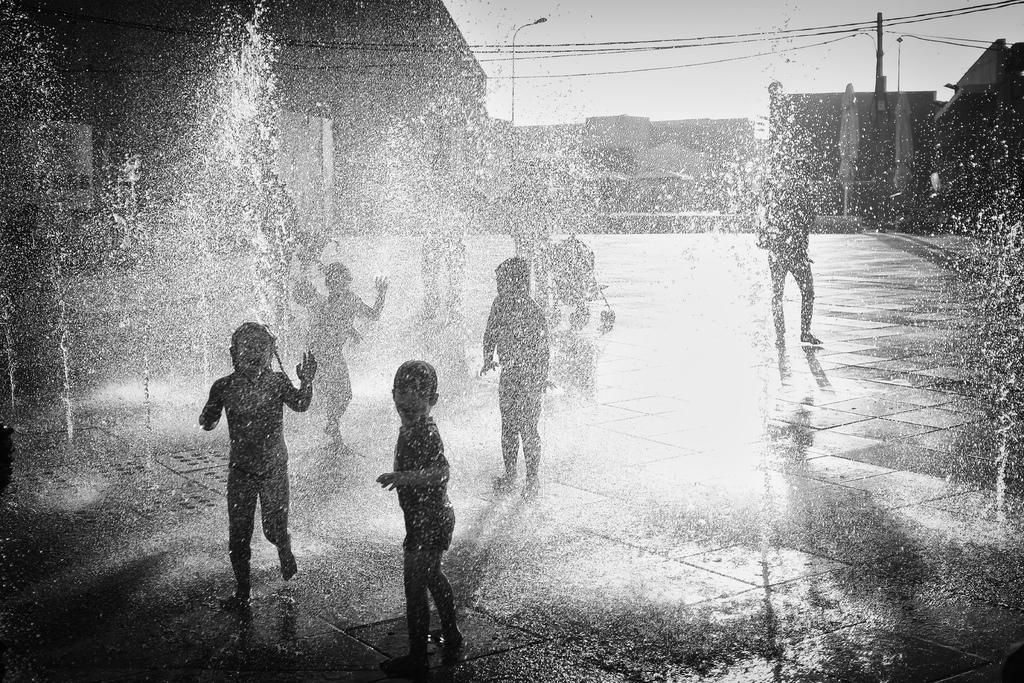What are the people in the image doing? The people in the image are standing in the middle. What is located near the people? There is a stroller in the image. What can be seen in the foreground of the image? Water is visible in the image. What is visible in the background of the image? There are poles and buildings in the background of the image. What is visible at the top of the image? The sky is visible at the top of the image. What type of rice is being cooked in the stroller in the image? There is no rice or cooking activity present in the image; the stroller is simply a stroller. 